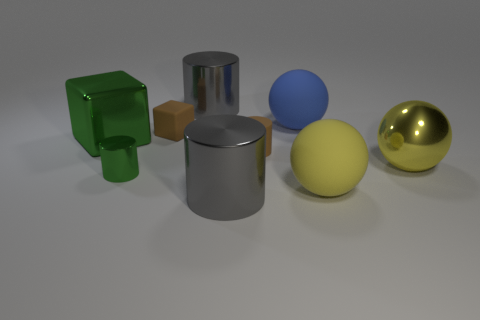There is a brown object that is to the left of the brown cylinder; is it the same size as the tiny metallic thing?
Offer a very short reply. Yes. How many matte objects have the same color as the big metal sphere?
Make the answer very short. 1. Do the big yellow metallic thing and the small green metallic object have the same shape?
Provide a short and direct response. No. Is there anything else that has the same size as the yellow metallic thing?
Provide a short and direct response. Yes. What is the size of the other matte thing that is the same shape as the tiny green object?
Your answer should be very brief. Small. Are there more big green objects on the left side of the big blue matte ball than large yellow metallic balls that are behind the tiny brown block?
Ensure brevity in your answer.  Yes. Does the large blue thing have the same material as the big gray cylinder behind the tiny brown cylinder?
Provide a short and direct response. No. Are there any other things that are the same shape as the big green metal thing?
Ensure brevity in your answer.  Yes. What color is the shiny cylinder that is in front of the blue matte ball and on the right side of the small green shiny object?
Make the answer very short. Gray. What shape is the green object behind the yellow metal ball?
Keep it short and to the point. Cube. 